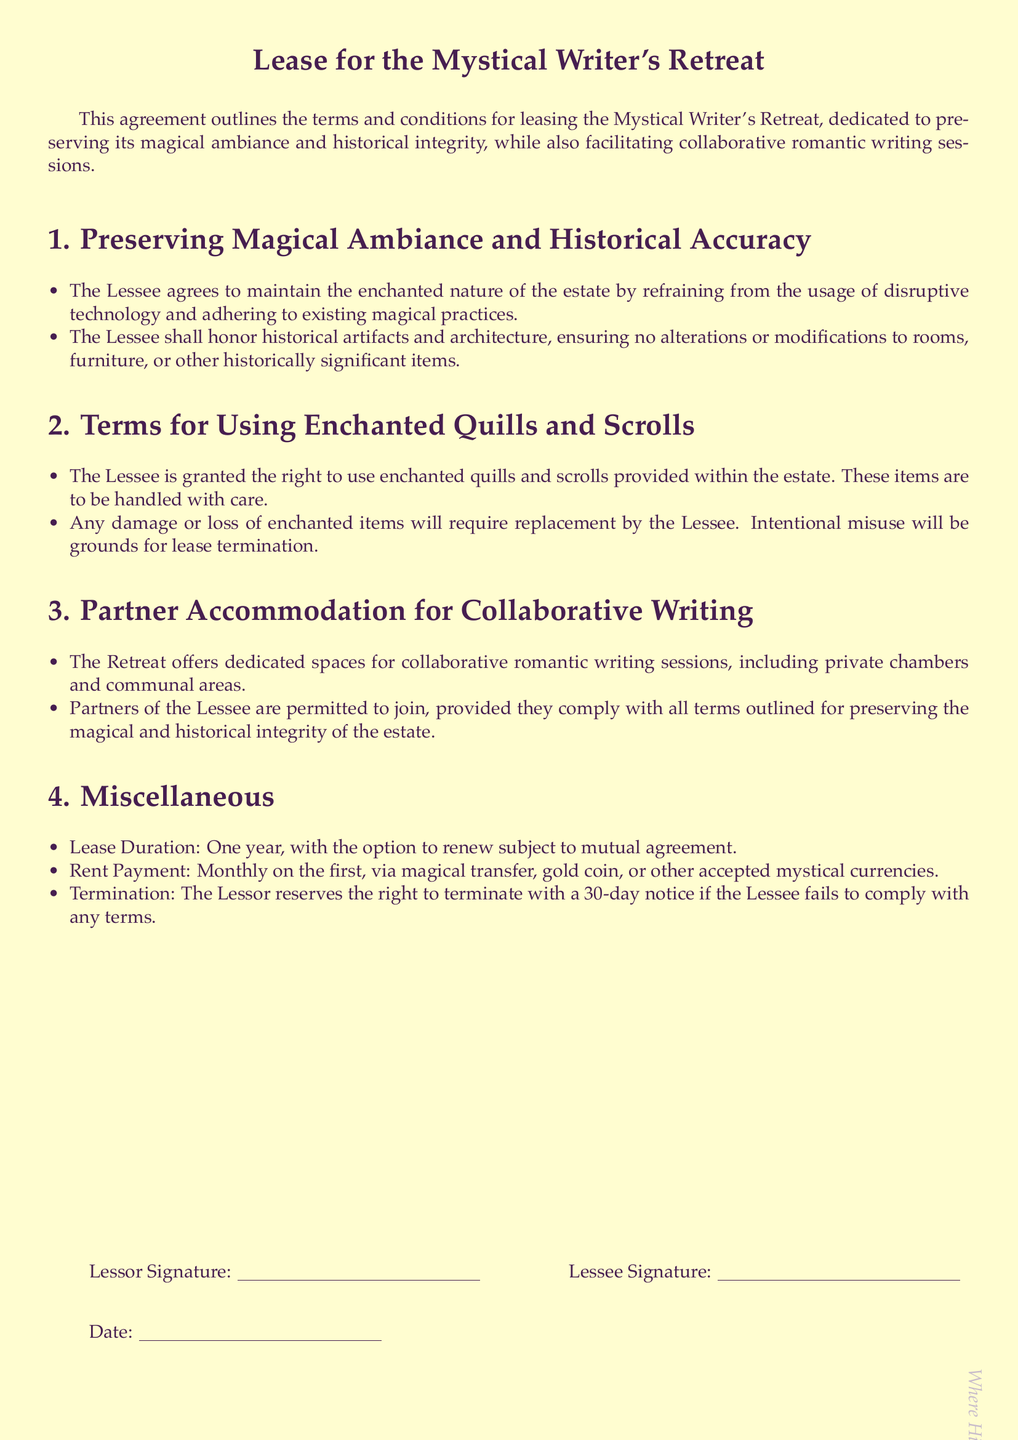What is the document title? The title of the document is stated prominently at the beginning, specifying the nature of the lease.
Answer: Lease for the Mystical Writer's Retreat How long is the lease duration? The lease duration is explicitly specified in the document and can be found under the miscellaneous section.
Answer: One year What type of payment is accepted for rent? The document outlines various payment methods acceptable for rent in the payment terms section.
Answer: Magical transfer, gold coin, or other accepted mystical currencies What must the Lessee not use to preserve the magical ambiance? The document specifies a restriction on certain technologies to maintain the estate's magical nature.
Answer: Disruptive technology What happens if the Lessee intentionally misuses enchanted items? The document details the consequences of misuse of enchanted items in terms of lease termination.
Answer: Grounds for lease termination What is required for partners of the Lessee to join? The document specifies the condition under which partners can use the facilities during their stay.
Answer: Compliance with all terms What must the Lessee do if enchanted items are damaged or lost? The document mentions the Lessee's responsibility regarding enchanted items under the terms section.
Answer: Require replacement by the Lessee What is the notice period for lease termination by the Lessor? The document states the duration of notice that must be given for lease termination.
Answer: 30-day notice 